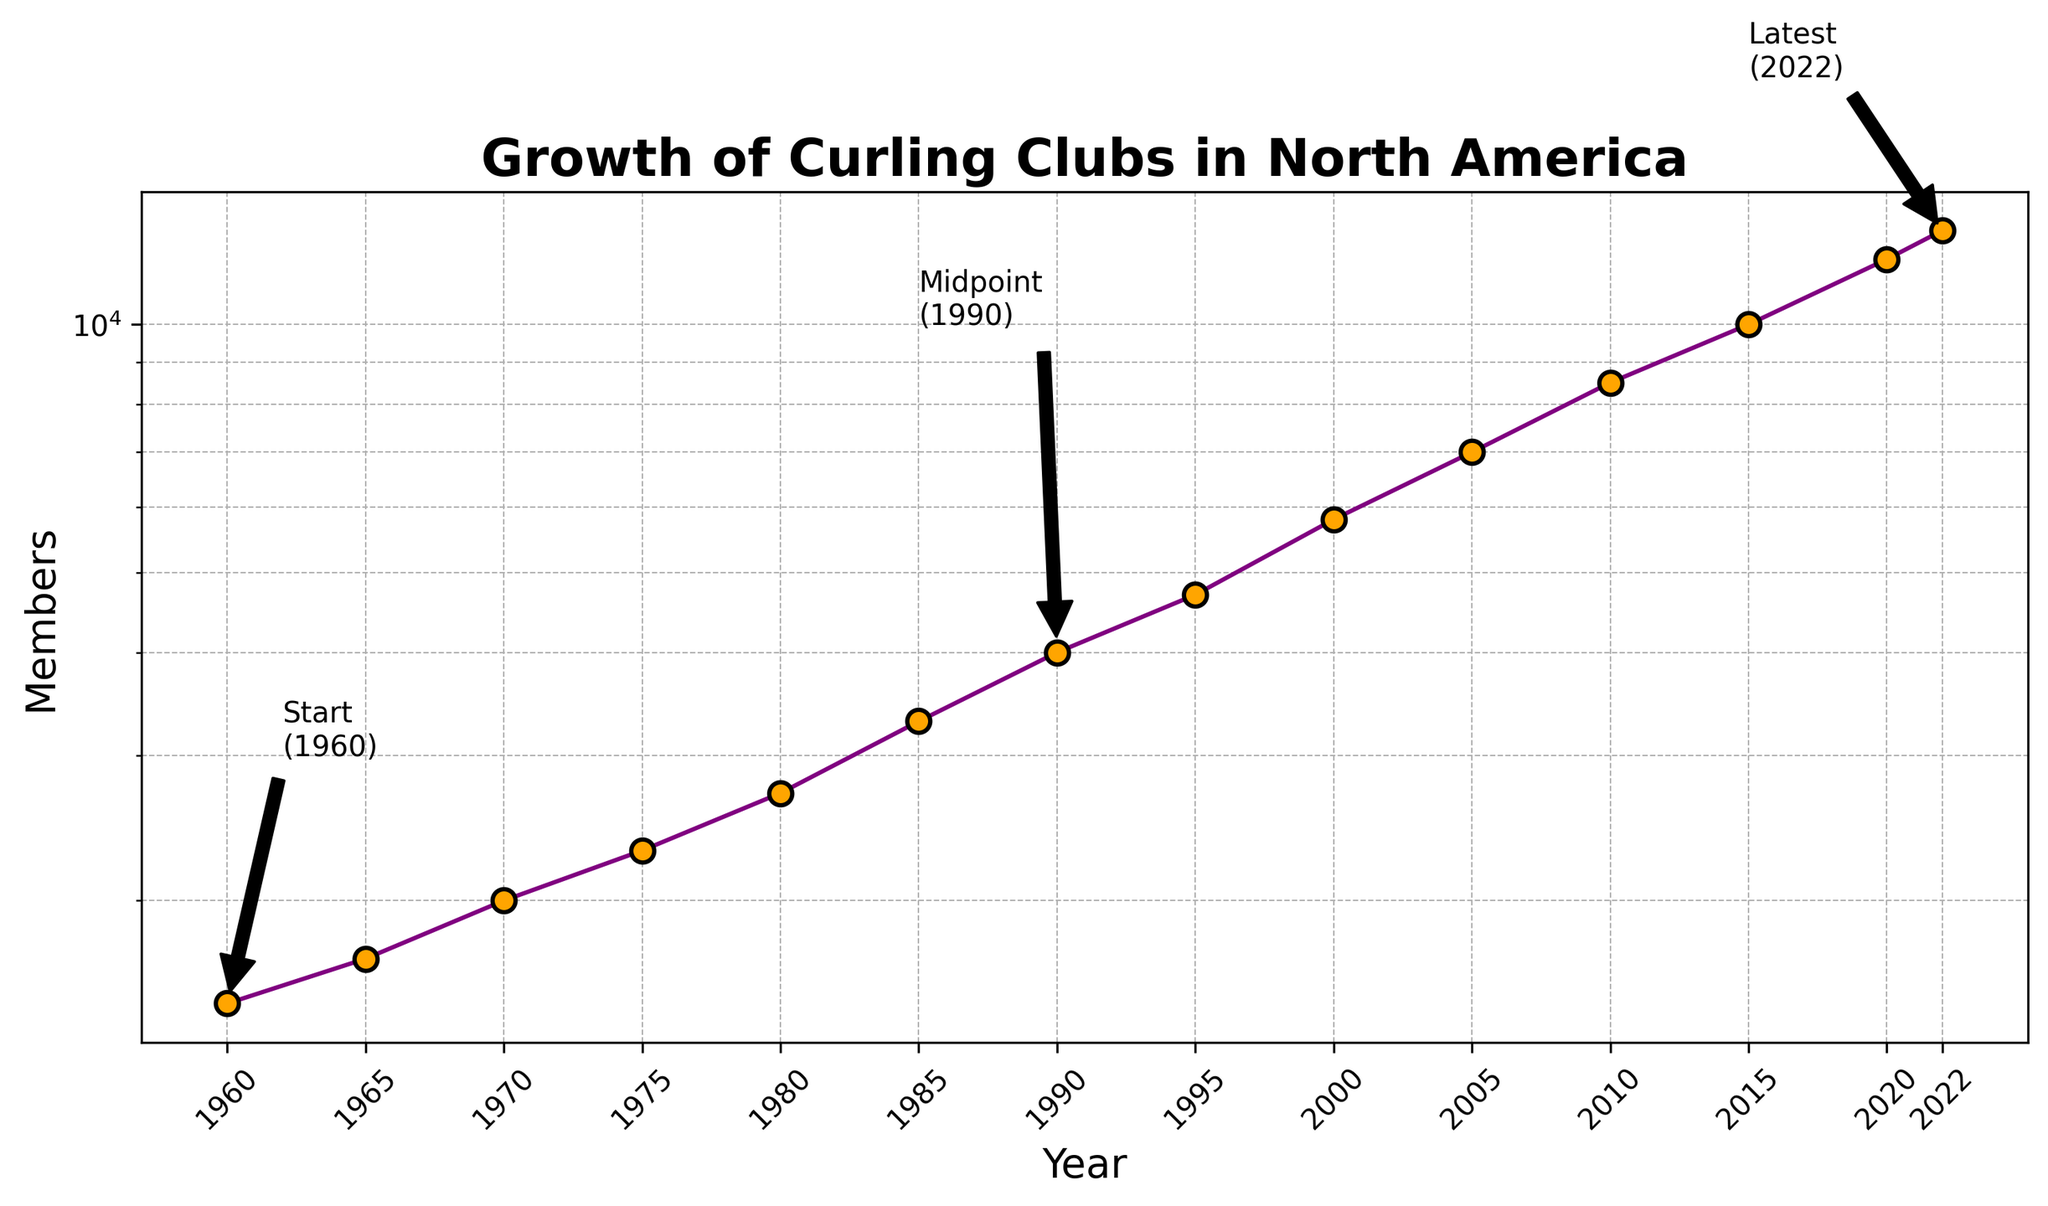what's the total growth in number of members from 1960 to 2022? To find the total growth, we need to subtract the number of members in 1960 from the number of members in 2022. The number of members in 1960 is 1500, and in 2022 it is 13000. So, 13000 - 1500 = 11500.
Answer: 11500 Which year saw the highest growth in the number of members compared to the previous recorded year? Look at the difference in the number of members between consecutive years. The biggest jump happens between 2005 (7000 members) and 2010 (8500 members), which is 1500 members.
Answer: 2010 How many years did it take for the number of members to increase from 5000 to 10000? We need to identify when the number of members was around 5000 and 10000. The number of members was 4700 in 1995, reaching 10000 in 2015. Thus, the time taken is 2015 - 1995 = 20 years.
Answer: 20 years In which year did the number of members first exceed 5000? Look at the values for each year to find when the number of members first goes past 5000. The number of members exceeded 5000 in the year 2000 (5800 members).
Answer: 2000 What is the approximate average growth in the number of members per decade? To find the average growth per decade: Subtract the members in 1960 from those in 2022 and divide by the number of decades. This gives (13000 - 1500) / 6.2 ≈ 1855 per decade.
Answer: ~1855 members per decade Which two years have the smallest increase in the number of members, and what is that increase? To find the smallest increase, compare the differences in member numbers between consecutive years. The smallest increase is between 2020 (12000 members) and 2022 (13000 members), which is an increase of 1000 members.
Answer: 2020-2022, 1000 members Compare the trend from 1960 to 1980 with the trend from 2000 to 2020. Which period showed a steeper increase in membership? Assess the slope by comparing the increase over these periods. From 1960 (1500) to 1980 (2700), the increase is 1200. From 2000 (5800) to 2020 (12000), the increase is 6200. The trend from 2000 to 2020 shows a steeper increase.
Answer: 2000-2020 Describe the change in the number of members from 1995 to 2005 in terms of percentage growth. The percentage growth is calculated by [(members in 2005 - members in 1995) / members in 1995] x 100. This gives [(7000 - 4700) / 4700] x 100 ≈ 49%.
Answer: ~49% How many annotations are added to the plot, and what do they indicate? There are three annotations indicating significant points: Start (1960), Midpoint (1990), and Latest (2022).
Answer: 3 What color is used to represent the markers on the plot? The markers on the plot are represented in orange color.
Answer: Orange 